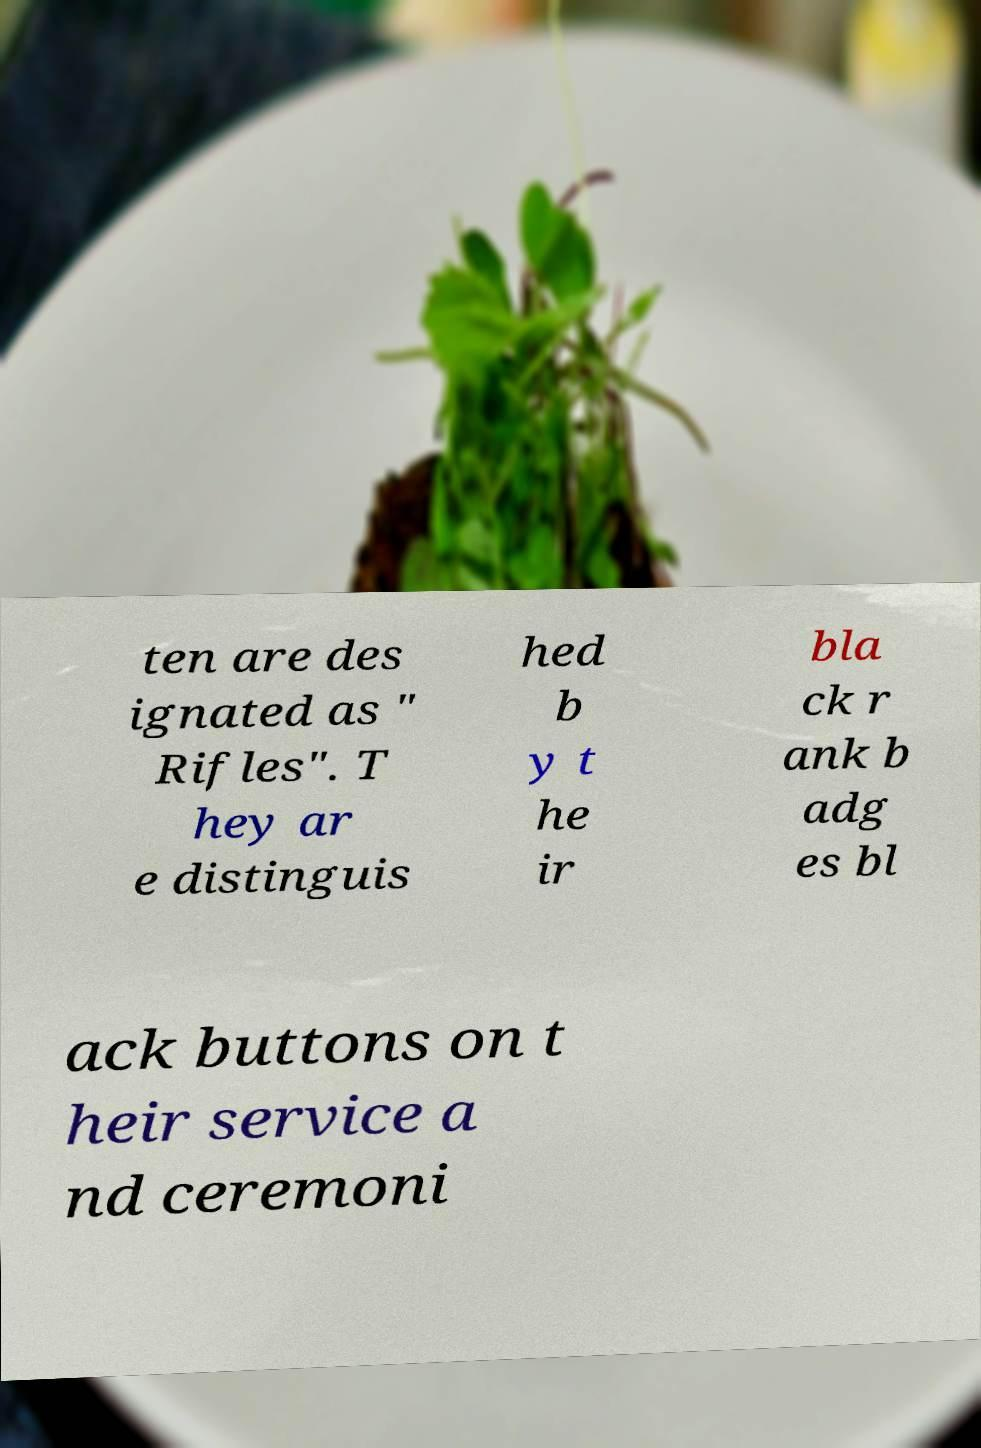Can you read and provide the text displayed in the image?This photo seems to have some interesting text. Can you extract and type it out for me? ten are des ignated as " Rifles". T hey ar e distinguis hed b y t he ir bla ck r ank b adg es bl ack buttons on t heir service a nd ceremoni 